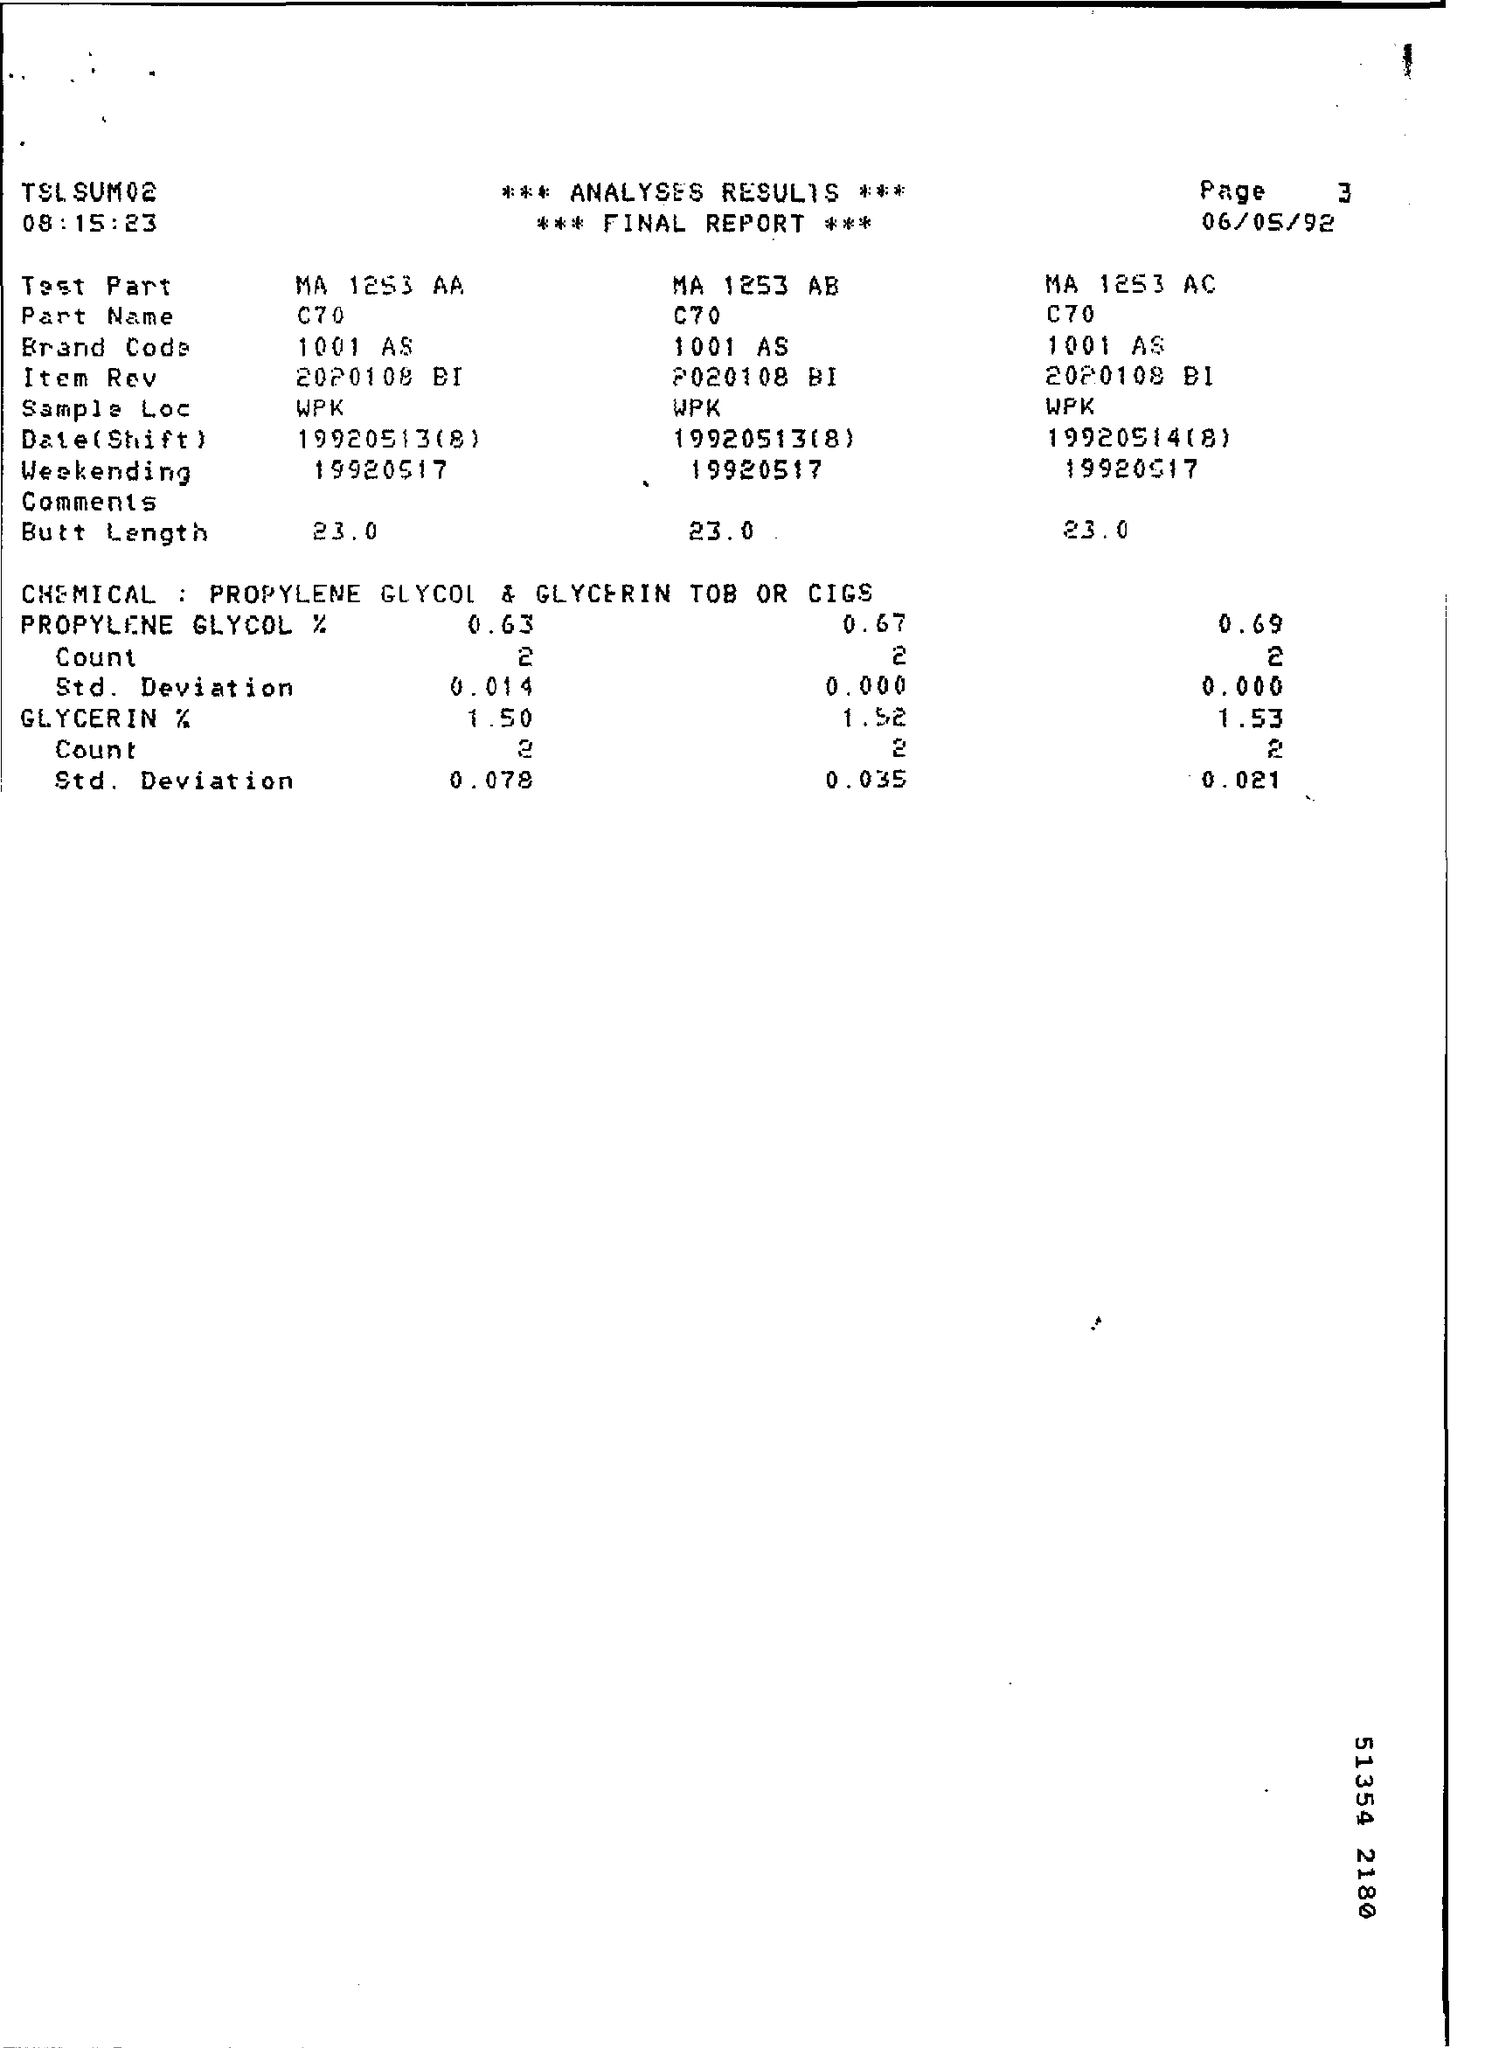Draw attention to some important aspects in this diagram. The page number is 3, as stated on page 3. The part name is C70.. The Sample Loc is a specified location for the collection of samples, typically used in scientific or research contexts, indicated by a unique identifier such as wpk.. The memorandum was dated on June 5, 1992. 